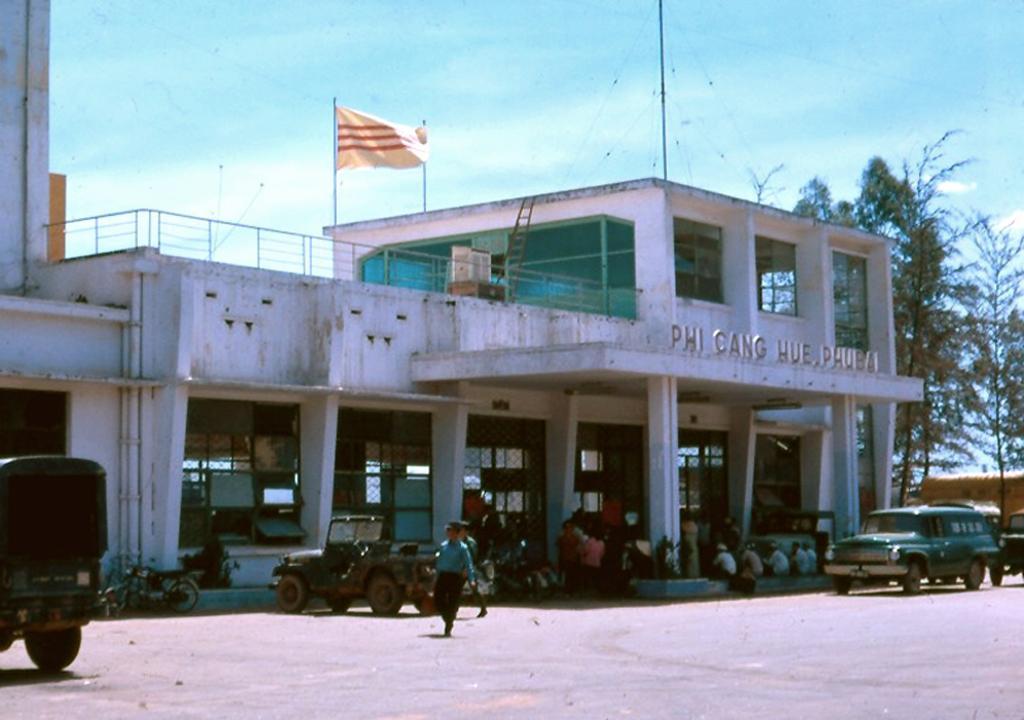Can you describe this image briefly? In this picture we can see vehicles on the ground, here we can see a building, people, trees, flagpoles and some objects and we can see sky in the background. 